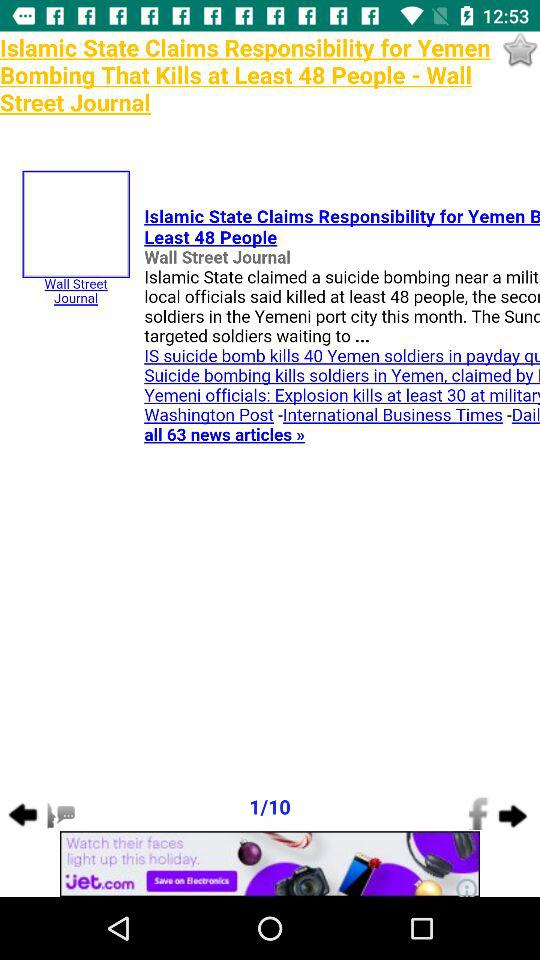Which page are we currently on? You are currently on the first page. 